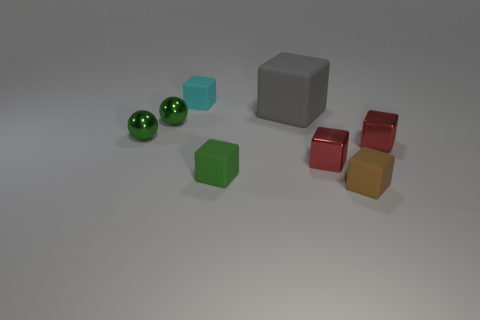Subtract all red blocks. How many blocks are left? 4 Subtract all cyan rubber cubes. How many cubes are left? 5 Subtract all yellow cubes. Subtract all green cylinders. How many cubes are left? 6 Add 1 big purple metal objects. How many objects exist? 9 Subtract all blocks. How many objects are left? 2 Add 5 small green blocks. How many small green blocks are left? 6 Add 1 big purple rubber blocks. How many big purple rubber blocks exist? 1 Subtract 0 purple cylinders. How many objects are left? 8 Subtract all small brown balls. Subtract all metal balls. How many objects are left? 6 